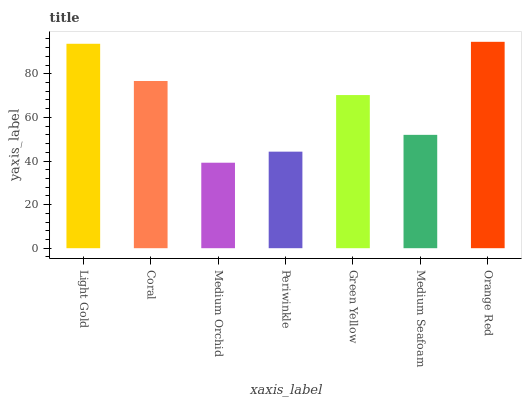Is Coral the minimum?
Answer yes or no. No. Is Coral the maximum?
Answer yes or no. No. Is Light Gold greater than Coral?
Answer yes or no. Yes. Is Coral less than Light Gold?
Answer yes or no. Yes. Is Coral greater than Light Gold?
Answer yes or no. No. Is Light Gold less than Coral?
Answer yes or no. No. Is Green Yellow the high median?
Answer yes or no. Yes. Is Green Yellow the low median?
Answer yes or no. Yes. Is Light Gold the high median?
Answer yes or no. No. Is Medium Seafoam the low median?
Answer yes or no. No. 